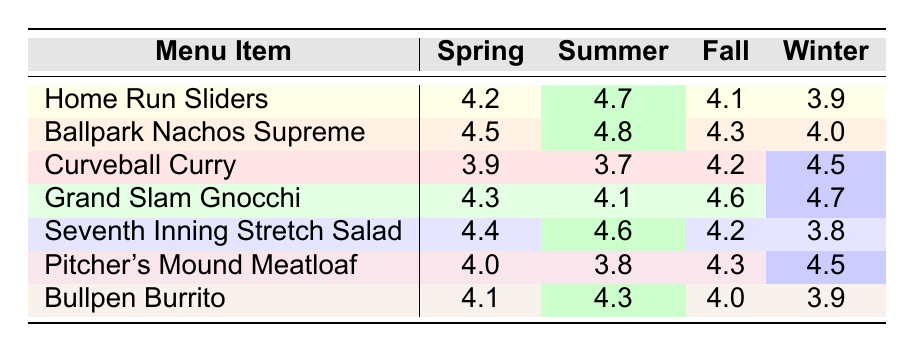What is the rating for "Home Run Sliders" in the summer? The table shows that the rating for "Home Run Sliders" in the summer is 4.7.
Answer: 4.7 Which menu item received the highest rating in the fall? By looking at the fall ratings, "Grand Slam Gnocchi" has the highest rating of 4.6.
Answer: Grand Slam Gnocchi What is the average rating for "Bullpen Burrito" across all seasons? The ratings are 4.1 (Spring), 4.3 (Summer), 4.0 (Fall), and 3.9 (Winter). Summing these gives 4.1 + 4.3 + 4.0 + 3.9 = 16.3. There are 4 seasons, so the average is 16.3/4 = 4.075.
Answer: 4.075 Did "Curveball Curry" have a higher rating in winter or spring? In winter, "Curveball Curry" has a rating of 4.5, whereas in spring, it has a rating of 3.9. Since 4.5 > 3.9, it had a higher rating in winter.
Answer: Yes, higher in winter Which season had the lowest rating for "Seventh Inning Stretch Salad"? The table indicates that "Seventh Inning Stretch Salad" has the lowest rating in winter at 3.8.
Answer: Winter What are the ratings for "Pitcher's Mound Meatloaf" in spring and summer? For "Pitcher's Mound Meatloaf," the rating in spring is 4.0 and in summer is 3.8.
Answer: 4.0 in spring, 3.8 in summer What is the difference between the highest and lowest ratings for "Ballpark Nachos Supreme"? The highest rating for "Ballpark Nachos Supreme" is 4.8 (Summer) and the lowest is 4.0 (Winter). The difference is 4.8 - 4.0 = 0.8.
Answer: 0.8 How many menu items have a rating of 4.5 or above in the fall? In the fall, the menu items with ratings of 4.5 or above are "Curveball Curry" (4.2), "Grand Slam Gnocchi" (4.6), and "Pitcher's Mound Meatloaf" (4.3), totaling 3 items.
Answer: 3 items Which menu item consistently had a rating above 4.0 in every season? Checking the ratings for each season, "Ballpark Nachos Supreme" has all ratings above 4.0: 4.5 (Spring), 4.8 (Summer), 4.3 (Fall), and 4.0 (Winter).
Answer: Ballpark Nachos Supreme What is the lowest rating received by "Grand Slam Gnocchi"? The lowest rating for "Grand Slam Gnocchi" is in summer, which is 4.1.
Answer: 4.1 How does the summer rating for "Curveball Curry" compare to that of "Bullpen Burrito"? The summer rating for "Curveball Curry" is 3.7, while for "Bullpen Burrito," it is 4.3. Since 4.3 > 3.7, "Bullpen Burrito" has a higher rating in summer.
Answer: Bullpen Burrito is higher 